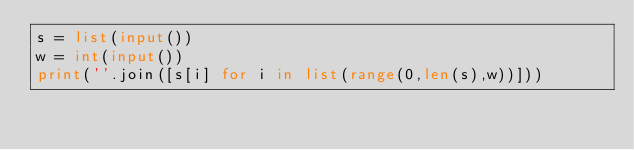<code> <loc_0><loc_0><loc_500><loc_500><_Python_>s = list(input())
w = int(input())
print(''.join([s[i] for i in list(range(0,len(s),w))]))
</code> 